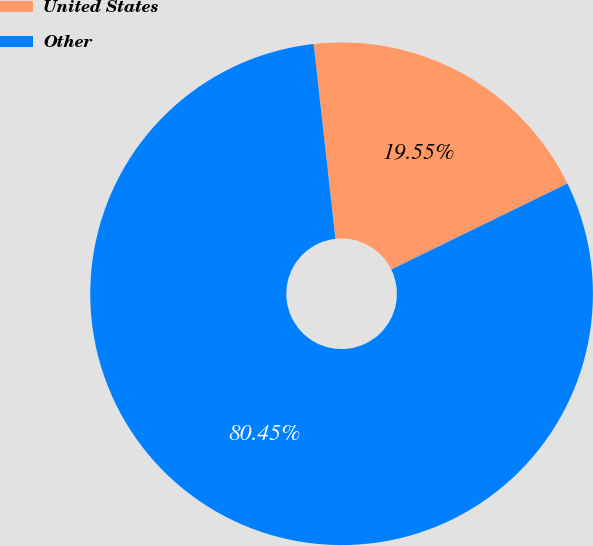Convert chart. <chart><loc_0><loc_0><loc_500><loc_500><pie_chart><fcel>United States<fcel>Other<nl><fcel>19.55%<fcel>80.45%<nl></chart> 